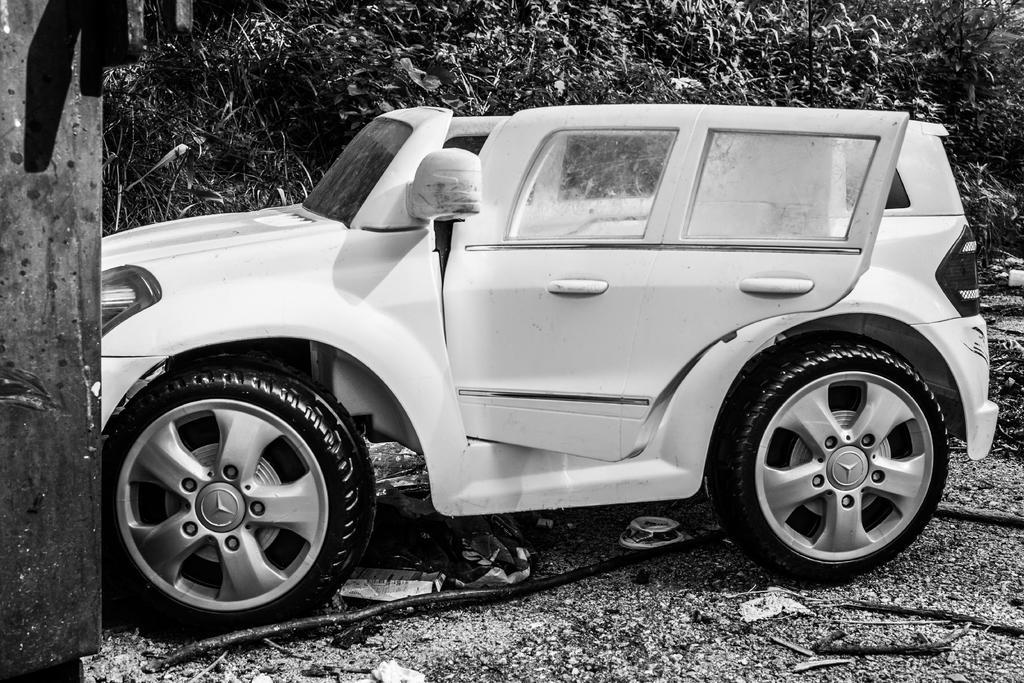Could you give a brief overview of what you see in this image? In the middle of this image, there is a white color vehicle having a door opened on the ground, on which there are a cable and sticks. In the background, there are trees. 